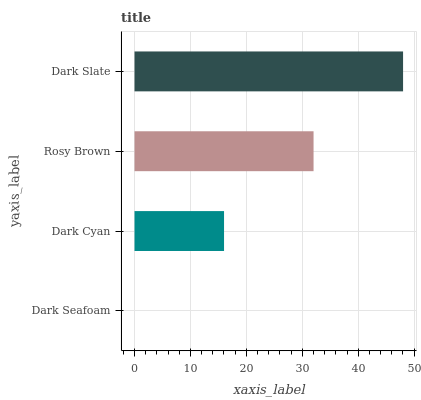Is Dark Seafoam the minimum?
Answer yes or no. Yes. Is Dark Slate the maximum?
Answer yes or no. Yes. Is Dark Cyan the minimum?
Answer yes or no. No. Is Dark Cyan the maximum?
Answer yes or no. No. Is Dark Cyan greater than Dark Seafoam?
Answer yes or no. Yes. Is Dark Seafoam less than Dark Cyan?
Answer yes or no. Yes. Is Dark Seafoam greater than Dark Cyan?
Answer yes or no. No. Is Dark Cyan less than Dark Seafoam?
Answer yes or no. No. Is Rosy Brown the high median?
Answer yes or no. Yes. Is Dark Cyan the low median?
Answer yes or no. Yes. Is Dark Cyan the high median?
Answer yes or no. No. Is Dark Seafoam the low median?
Answer yes or no. No. 